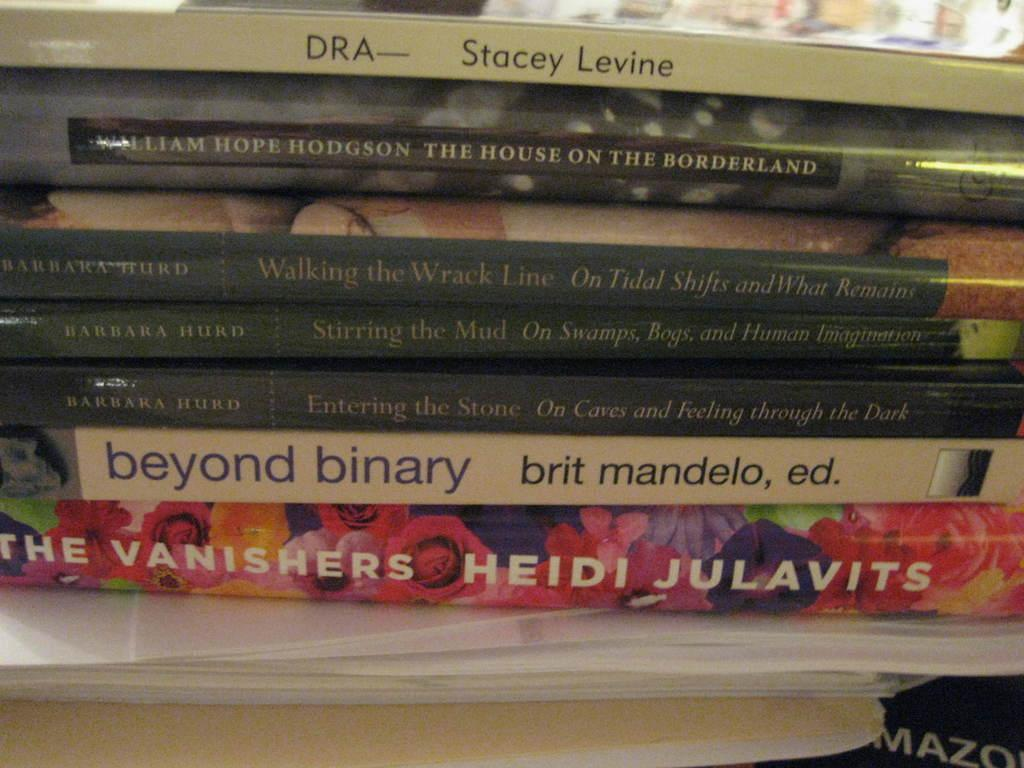<image>
Give a short and clear explanation of the subsequent image. A stack of books including one title beyond binary 